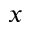Convert formula to latex. <formula><loc_0><loc_0><loc_500><loc_500>x</formula> 